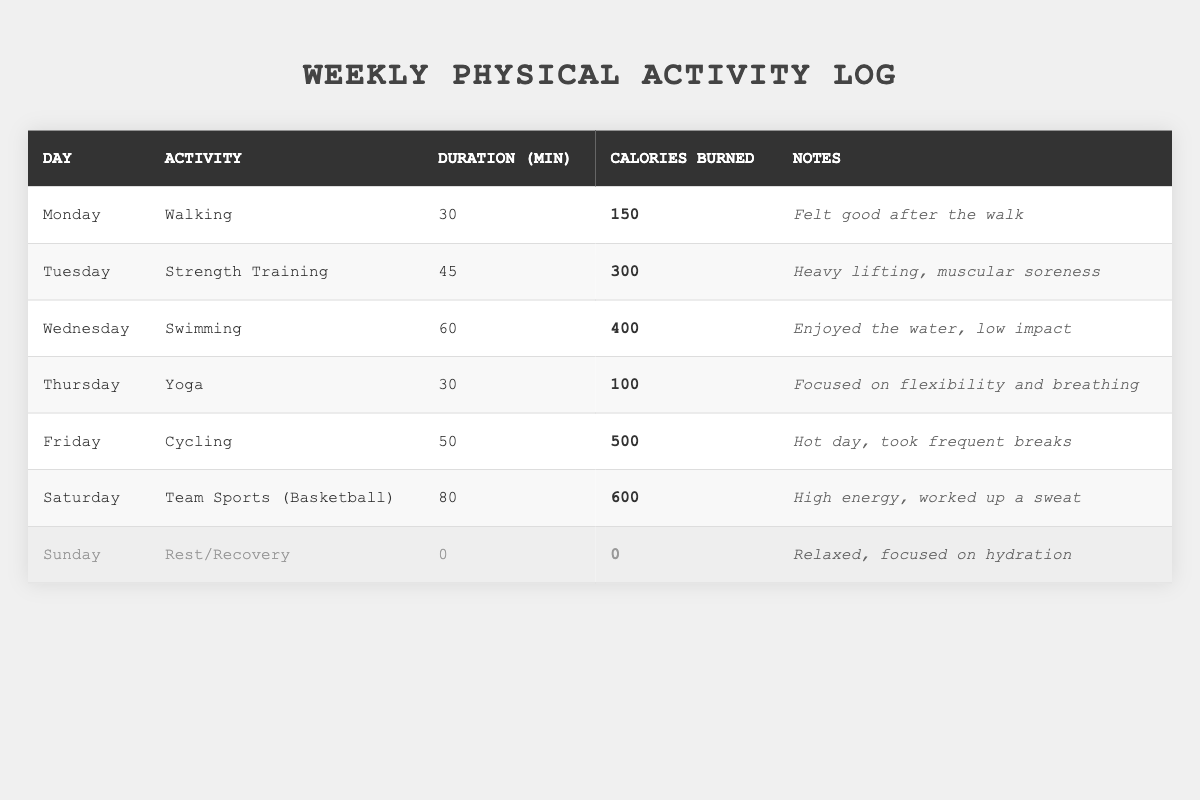What activity did I do on Wednesday? The table lists the activities for each day, and under Wednesday, the activity is "Swimming."
Answer: Swimming What was the total duration of physical activities for the week? To find the total duration, sum the durations: 30 (Walking) + 45 (Strength Training) + 60 (Swimming) + 30 (Yoga) + 50 (Cycling) + 80 (Basketball) + 0 (Rest) = 295 minutes.
Answer: 295 minutes How many calories did I burn on Monday? Looking at the table, under Monday, the calories burned for walking is listed as 150.
Answer: 150 calories What was my highest calorie burn activity for the week? The table shows the calories burned for each activity. The highest value is 600 calories burned during Team Sports (Basketball) on Saturday.
Answer: 600 calories What is the average duration of my activities for the week? First, calculate the total duration: 30 + 45 + 60 + 30 + 50 + 80 + 0 = 295 minutes. There are 6 days of activity, so the average is 295 / 6 = 49.17 minutes.
Answer: 49.17 minutes Did I have any rest days during the week? The table clearly states that Sunday is designated as "Rest/Recovery," which indicates a rest day.
Answer: Yes What was the total number of calories burned across all activities? To find the total calories, sum the values: 150 (Walking) + 300 (Strength Training) + 400 (Swimming) + 100 (Yoga) + 500 (Cycling) + 600 (Basketball) + 0 (Rest) = 2050 calories.
Answer: 2050 calories What percentage of calories burned came from cycling? Cycling burned 500 calories out of a total of 2050 calories. To find the percentage, (500/2050) * 100 = 24.39%.
Answer: 24.39% Which activity required the least duration? The table shows that the shortest activity is Yoga with a duration of 30 minutes on Thursday.
Answer: Yoga Did I feel good after my physical activities throughout the week? The notes indicate that I felt good after the walk on Monday, but on Tuesday I noted muscular soreness, which suggests mixed feelings; however, there is no summary for other days in the notes regarding feelings.
Answer: Mixed feelings 